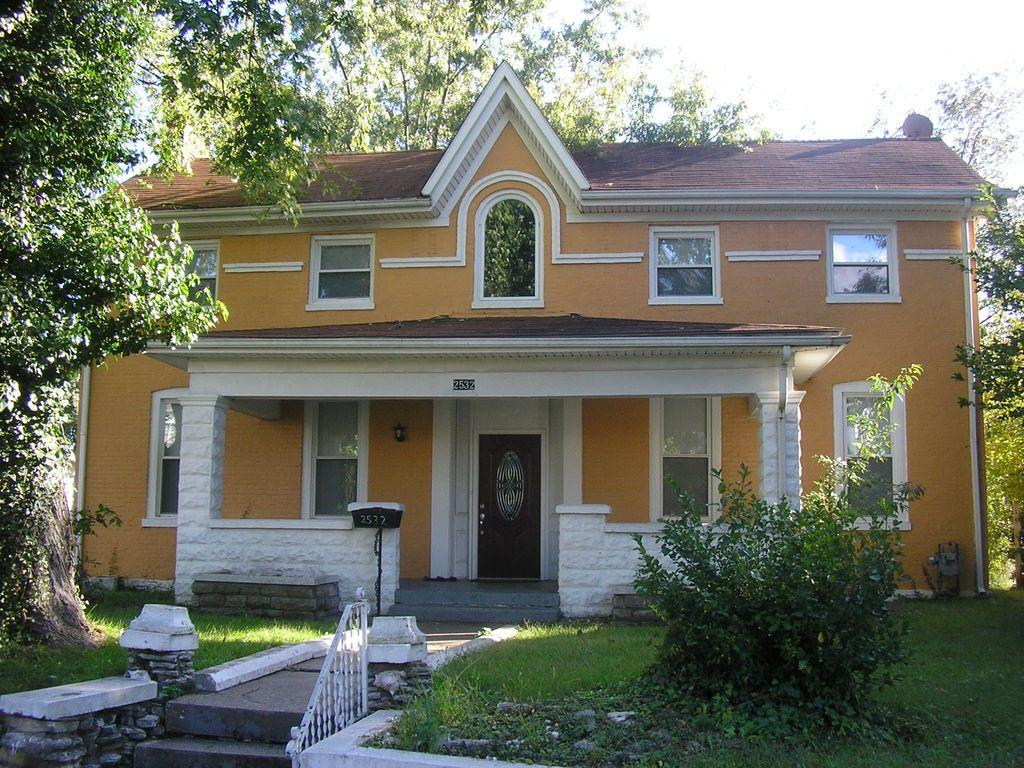What type of structure is visible in the image? There is a building in the image. What natural elements can be seen in the image? There are trees and grass present in the image. What architectural features are visible in the image? There is a railing and stairs in the image. What can be seen in the background of the image? The sky is visible in the background of the image. How many jellyfish are swimming in the image? There are no jellyfish present in the image; it features a building, trees, grass, a railing, stairs, and the sky. 